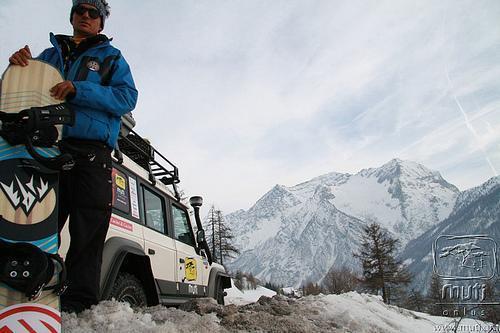How many people are in the photo?
Give a very brief answer. 1. 